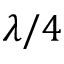Convert formula to latex. <formula><loc_0><loc_0><loc_500><loc_500>\lambda / 4</formula> 